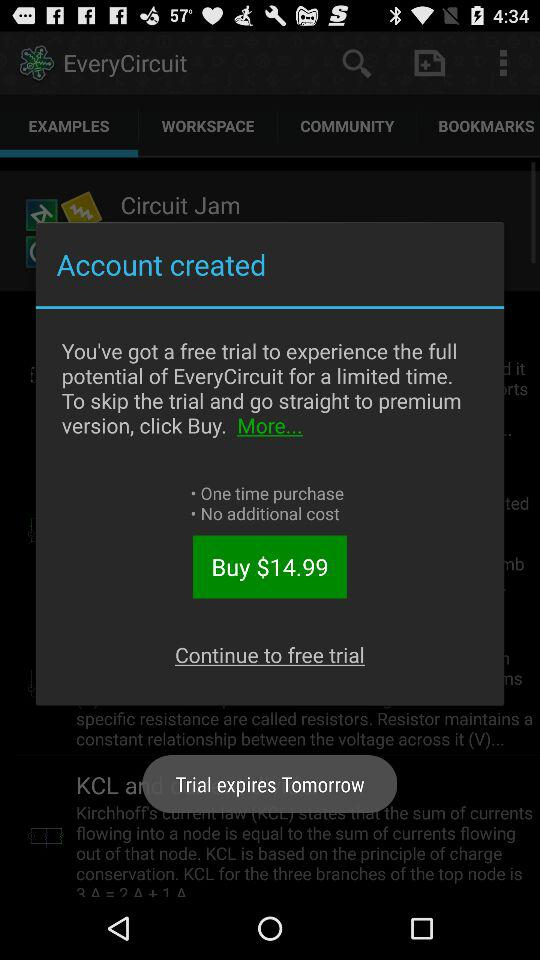What is the price to buy the premium version? The price to buy the premium version is $14.99. 